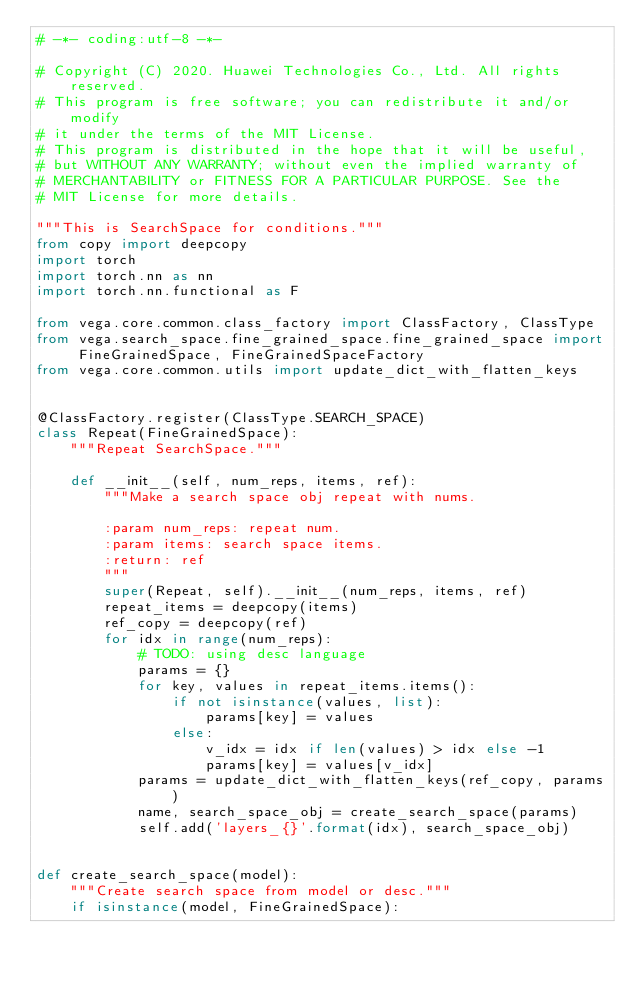Convert code to text. <code><loc_0><loc_0><loc_500><loc_500><_Python_># -*- coding:utf-8 -*-

# Copyright (C) 2020. Huawei Technologies Co., Ltd. All rights reserved.
# This program is free software; you can redistribute it and/or modify
# it under the terms of the MIT License.
# This program is distributed in the hope that it will be useful,
# but WITHOUT ANY WARRANTY; without even the implied warranty of
# MERCHANTABILITY or FITNESS FOR A PARTICULAR PURPOSE. See the
# MIT License for more details.

"""This is SearchSpace for conditions."""
from copy import deepcopy
import torch
import torch.nn as nn
import torch.nn.functional as F

from vega.core.common.class_factory import ClassFactory, ClassType
from vega.search_space.fine_grained_space.fine_grained_space import FineGrainedSpace, FineGrainedSpaceFactory
from vega.core.common.utils import update_dict_with_flatten_keys


@ClassFactory.register(ClassType.SEARCH_SPACE)
class Repeat(FineGrainedSpace):
    """Repeat SearchSpace."""

    def __init__(self, num_reps, items, ref):
        """Make a search space obj repeat with nums.

        :param num_reps: repeat num.
        :param items: search space items.
        :return: ref
        """
        super(Repeat, self).__init__(num_reps, items, ref)
        repeat_items = deepcopy(items)
        ref_copy = deepcopy(ref)
        for idx in range(num_reps):
            # TODO: using desc language
            params = {}
            for key, values in repeat_items.items():
                if not isinstance(values, list):
                    params[key] = values
                else:
                    v_idx = idx if len(values) > idx else -1
                    params[key] = values[v_idx]
            params = update_dict_with_flatten_keys(ref_copy, params)
            name, search_space_obj = create_search_space(params)
            self.add('layers_{}'.format(idx), search_space_obj)


def create_search_space(model):
    """Create search space from model or desc."""
    if isinstance(model, FineGrainedSpace):</code> 